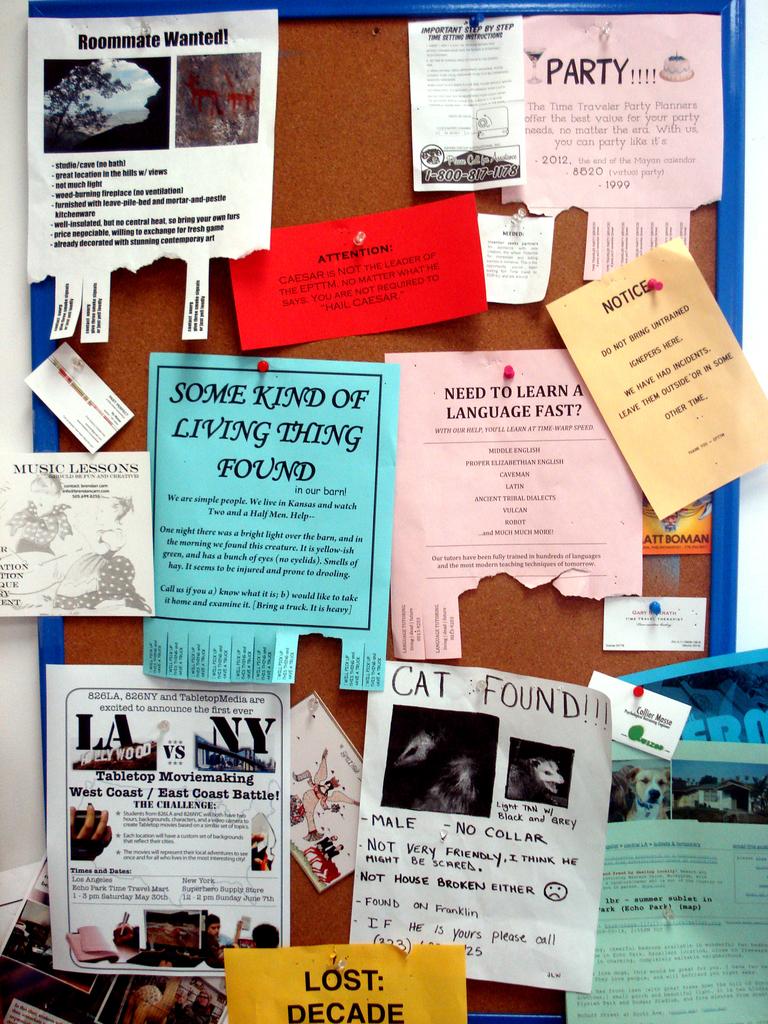Has anyone found the lost cat?
Provide a succinct answer. Yes. 